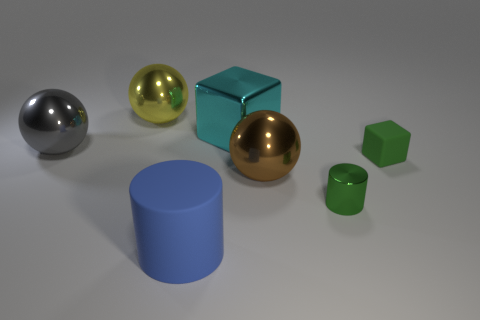What is the color of the matte thing that is the same size as the green metal object?
Keep it short and to the point. Green. Are there the same number of yellow things right of the shiny cylinder and gray blocks?
Offer a very short reply. Yes. The metallic thing that is left of the tiny green metallic cylinder and in front of the green cube has what shape?
Provide a short and direct response. Sphere. Does the green shiny object have the same size as the rubber block?
Provide a succinct answer. Yes. Is there a tiny cylinder made of the same material as the green cube?
Your response must be concise. No. The cylinder that is the same color as the rubber cube is what size?
Provide a short and direct response. Small. How many things are on the right side of the big gray metallic object and on the left side of the matte cube?
Ensure brevity in your answer.  5. What is the cylinder to the left of the large block made of?
Keep it short and to the point. Rubber. What number of rubber cylinders have the same color as the matte cube?
Provide a short and direct response. 0. The yellow ball that is the same material as the green cylinder is what size?
Your answer should be compact. Large. 